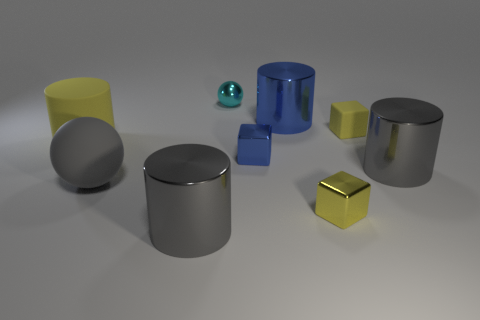What number of things are cubes that are behind the blue cube or big cubes?
Give a very brief answer. 1. There is a big rubber ball; does it have the same color as the big metallic cylinder that is on the right side of the small yellow metal block?
Ensure brevity in your answer.  Yes. What is the size of the gray cylinder on the right side of the small blue object that is on the right side of the cyan ball?
Your answer should be very brief. Large. What number of objects are either tiny green spheres or large shiny things in front of the blue metallic cylinder?
Your answer should be very brief. 2. Does the small yellow object in front of the large yellow matte cylinder have the same shape as the tiny yellow matte object?
Your answer should be very brief. Yes. There is a large metal cylinder that is in front of the yellow block that is in front of the large gray rubber sphere; how many yellow objects are right of it?
Your response must be concise. 2. Are there any other things that have the same shape as the small blue object?
Ensure brevity in your answer.  Yes. How many things are either yellow rubber blocks or large red matte cubes?
Make the answer very short. 1. There is a tiny yellow shiny object; is it the same shape as the big gray object to the right of the large blue shiny object?
Give a very brief answer. No. What shape is the yellow thing that is on the left side of the blue shiny cube?
Your answer should be very brief. Cylinder. 